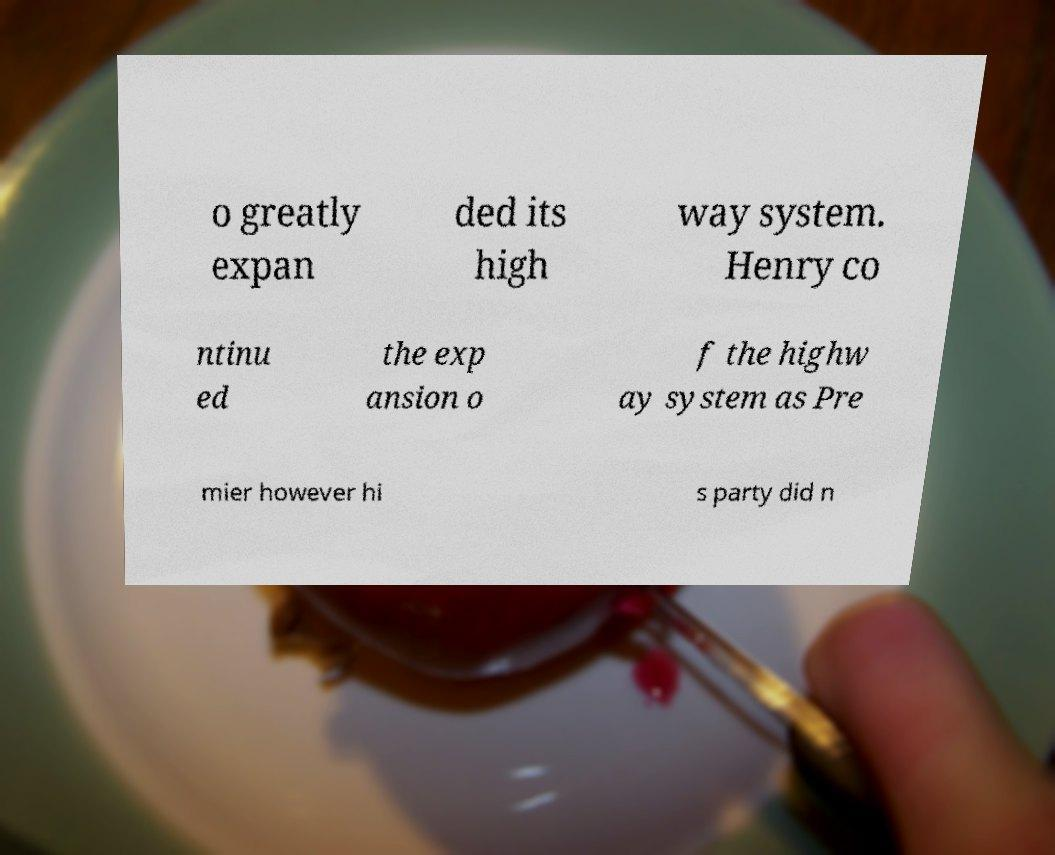Can you read and provide the text displayed in the image?This photo seems to have some interesting text. Can you extract and type it out for me? o greatly expan ded its high way system. Henry co ntinu ed the exp ansion o f the highw ay system as Pre mier however hi s party did n 